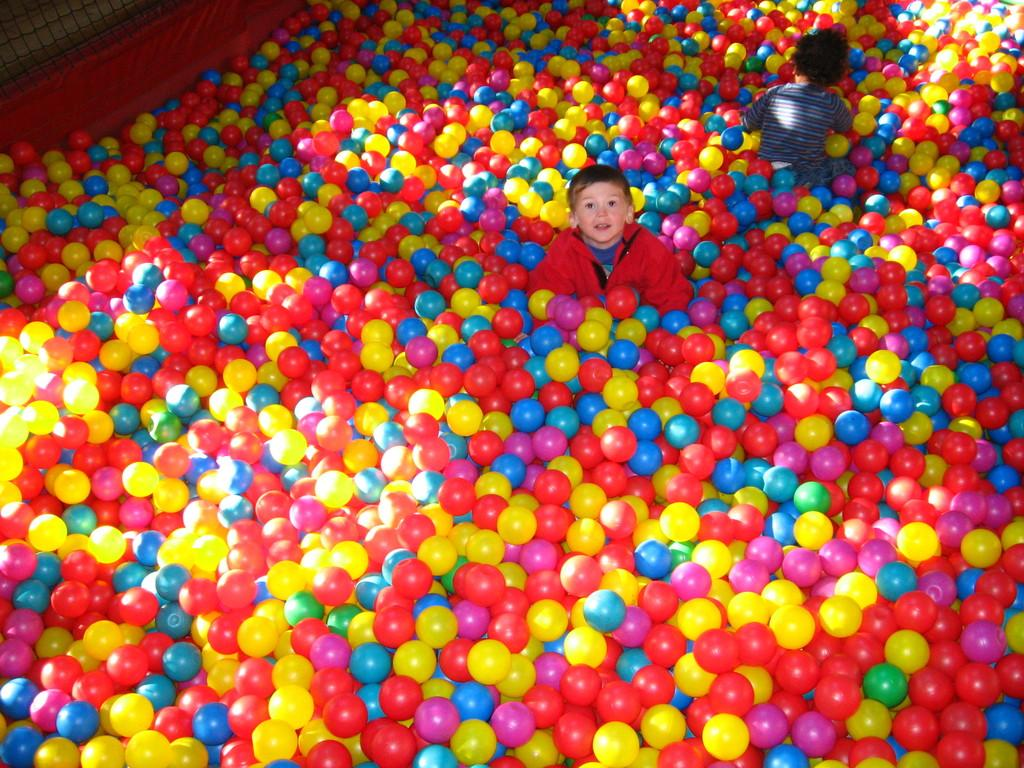How many boys are present in the image? There are two boys in the image. What are the boys doing in the image? The boys are playing with balls. Can you describe the balls in the image? There is a group of balls at the bottom of the image. What can be seen in the background of the image? There is a net and a cloth in the background of the image. What type of digestion issues are the boys experiencing while playing with the balls in the image? There is no indication in the image that the boys are experiencing any digestion issues. Can you tell me how many goats are present in the image? There are no goats present in the image; it features two boys playing with balls. 